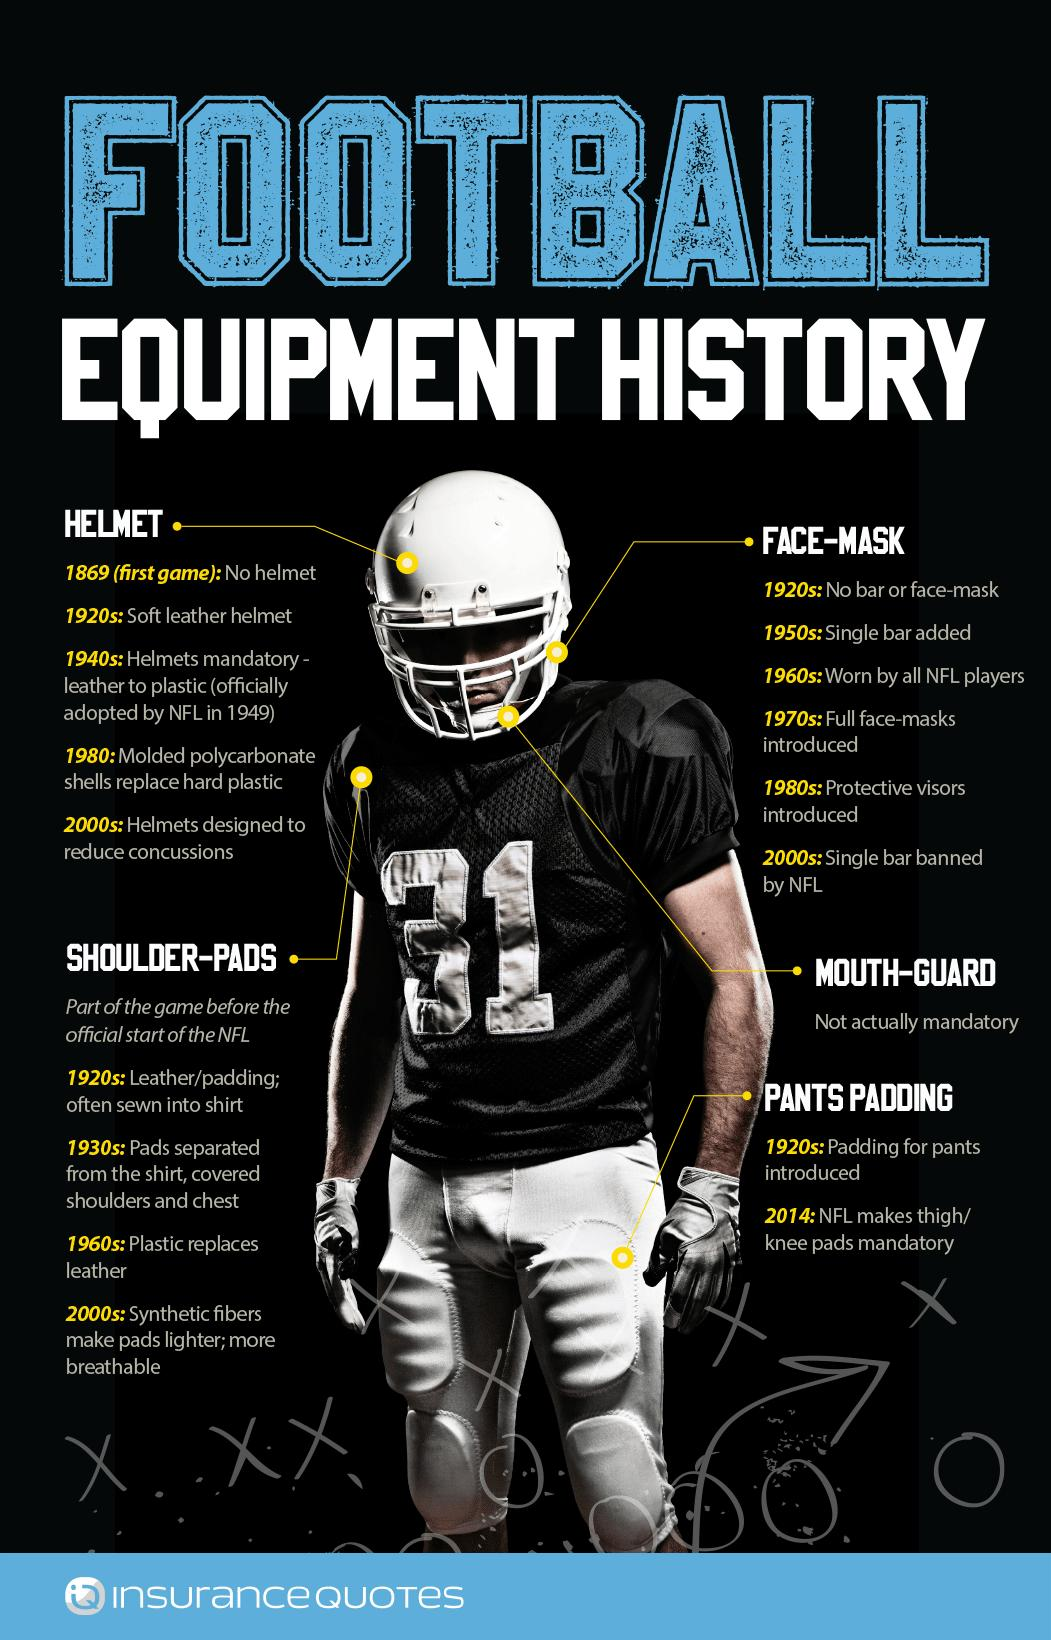List a handful of essential elements in this visual. The design of specialized headgear to prevent injuries was introduced in the 1980s, with further developments made in the 2000s, and it was first introduced in the 1970s. The lightweight pads for the shoulders were introduced in the 1960s. The padding on pants became compulsory in 2014. While playing football, the use of mouth-guards is not mandatory, making it an optional piece of equipment. I am in possession of information that the player's jersey number is 31. 